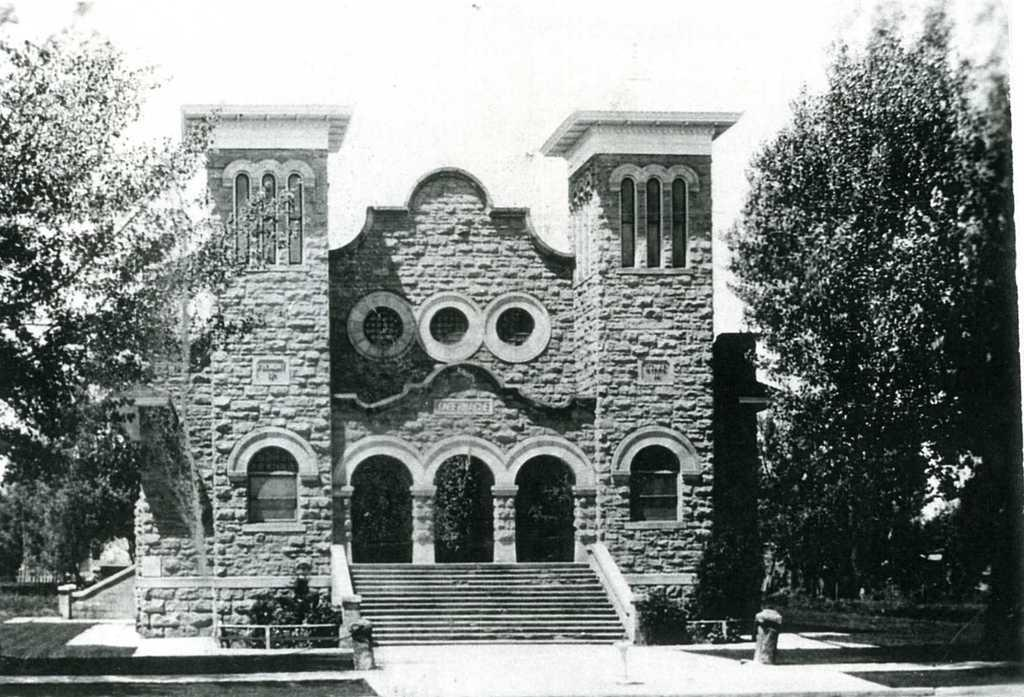What is the color scheme of the image? The image is black and white. What is the main structure in the image? There is a fort in the image. What type of vegetation surrounds the fort? There are trees around the fort. How many doors are at the entrance of the fort? There are three doors at the entrance of the fort. What type of caption is written on the fort in the image? There is no caption written on the fort in the image, as it is a black and white image and captions are typically text-based. How does the cabbage feel about being near the fort in the image? There is no cabbage present in the image, so it is not possible to determine how it might feel about being near the fort. 